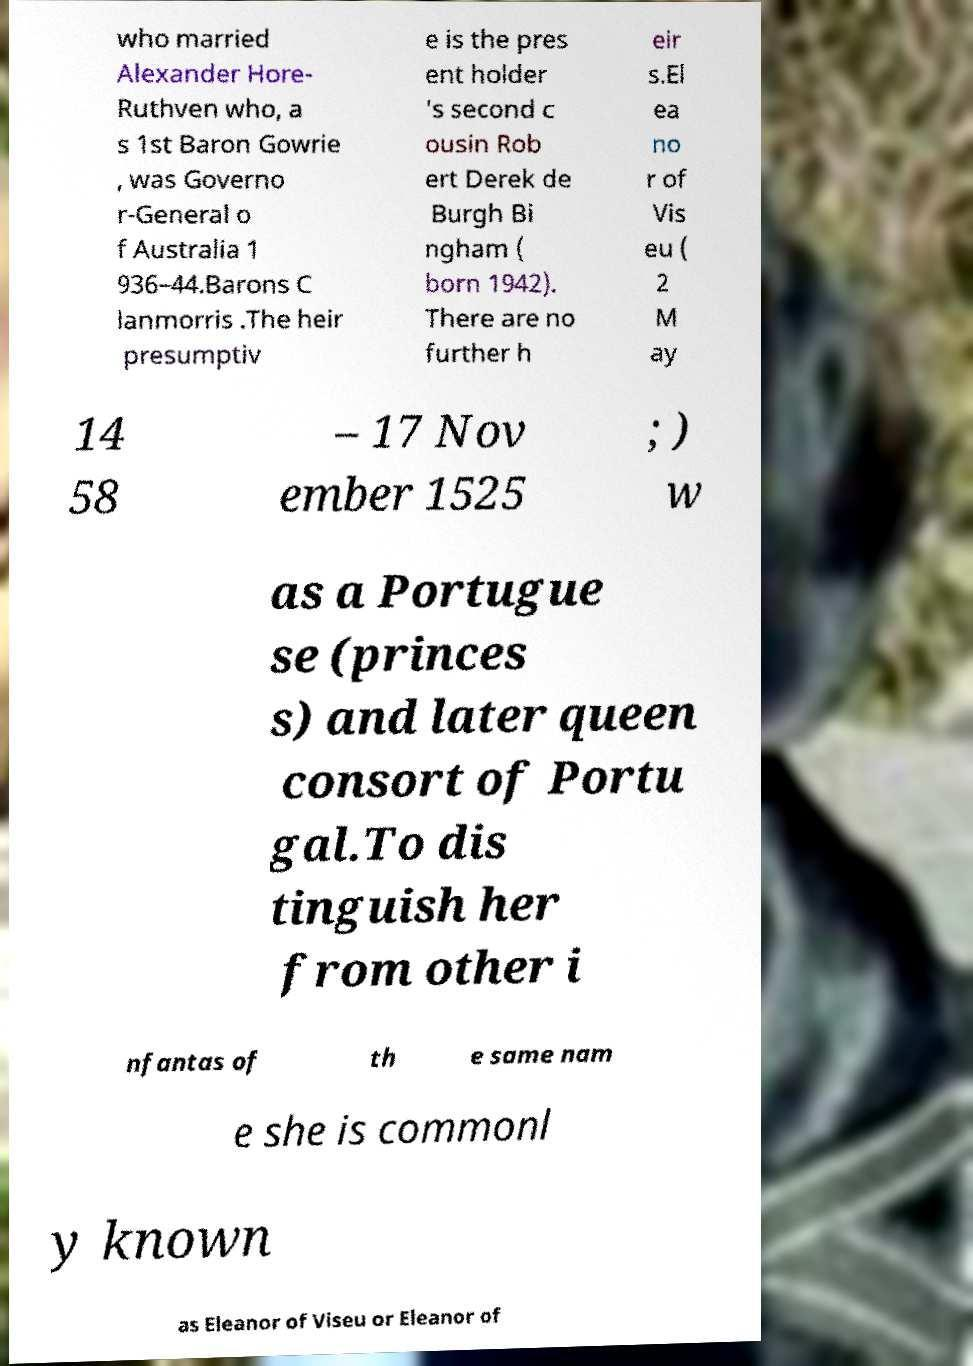I need the written content from this picture converted into text. Can you do that? who married Alexander Hore- Ruthven who, a s 1st Baron Gowrie , was Governo r-General o f Australia 1 936–44.Barons C lanmorris .The heir presumptiv e is the pres ent holder 's second c ousin Rob ert Derek de Burgh Bi ngham ( born 1942). There are no further h eir s.El ea no r of Vis eu ( 2 M ay 14 58 – 17 Nov ember 1525 ; ) w as a Portugue se (princes s) and later queen consort of Portu gal.To dis tinguish her from other i nfantas of th e same nam e she is commonl y known as Eleanor of Viseu or Eleanor of 